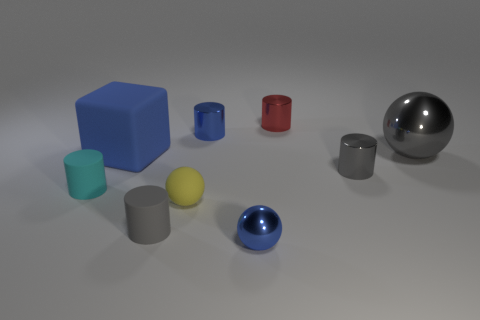Subtract all gray metallic cylinders. How many cylinders are left? 4 Subtract all red cylinders. How many cylinders are left? 4 Subtract all red cylinders. Subtract all red balls. How many cylinders are left? 4 Subtract all balls. How many objects are left? 6 Add 6 rubber blocks. How many rubber blocks exist? 7 Subtract 0 cyan blocks. How many objects are left? 9 Subtract all red cylinders. Subtract all small rubber things. How many objects are left? 5 Add 4 tiny yellow matte objects. How many tiny yellow matte objects are left? 5 